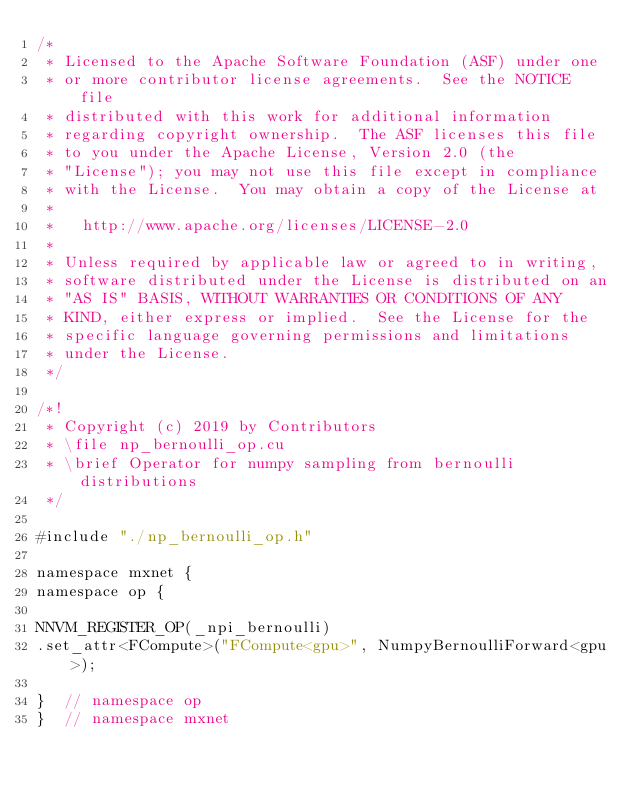<code> <loc_0><loc_0><loc_500><loc_500><_Cuda_>/*
 * Licensed to the Apache Software Foundation (ASF) under one
 * or more contributor license agreements.  See the NOTICE file
 * distributed with this work for additional information
 * regarding copyright ownership.  The ASF licenses this file
 * to you under the Apache License, Version 2.0 (the
 * "License"); you may not use this file except in compliance
 * with the License.  You may obtain a copy of the License at
 *
 *   http://www.apache.org/licenses/LICENSE-2.0
 *
 * Unless required by applicable law or agreed to in writing,
 * software distributed under the License is distributed on an
 * "AS IS" BASIS, WITHOUT WARRANTIES OR CONDITIONS OF ANY
 * KIND, either express or implied.  See the License for the
 * specific language governing permissions and limitations
 * under the License.
 */

/*!
 * Copyright (c) 2019 by Contributors
 * \file np_bernoulli_op.cu
 * \brief Operator for numpy sampling from bernoulli distributions
 */

#include "./np_bernoulli_op.h"

namespace mxnet {
namespace op {

NNVM_REGISTER_OP(_npi_bernoulli)
.set_attr<FCompute>("FCompute<gpu>", NumpyBernoulliForward<gpu>);

}  // namespace op
}  // namespace mxnet
</code> 